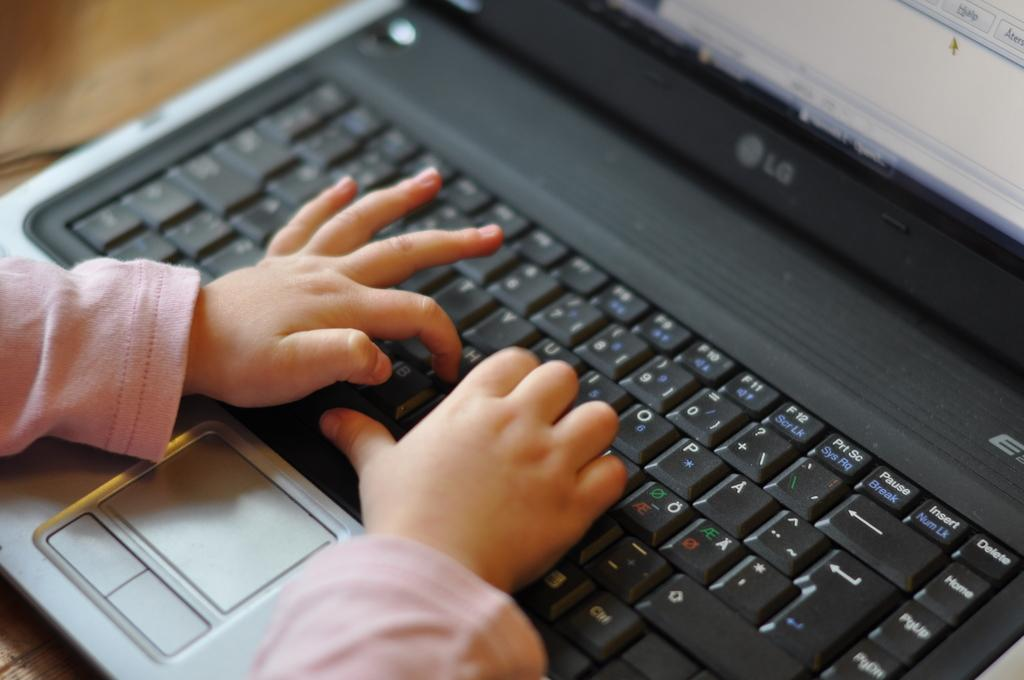<image>
Describe the image concisely. Person using an LG keyboard that has small hands. 